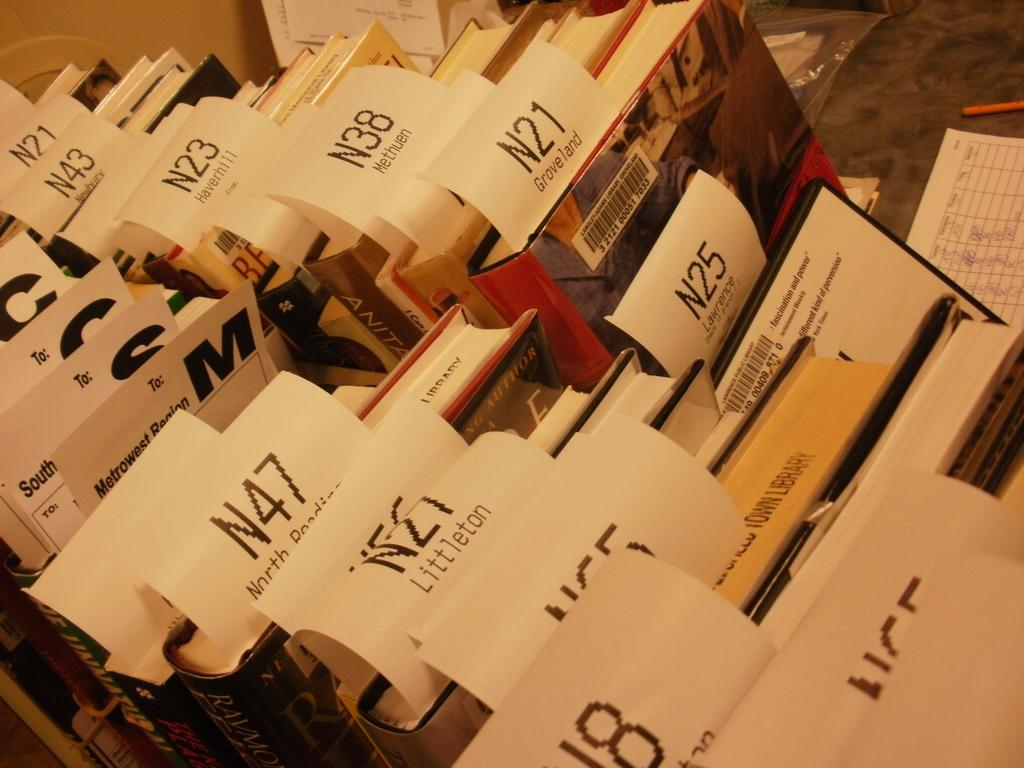<image>
Give a short and clear explanation of the subsequent image. a piece of paper with N21 at the top of it 